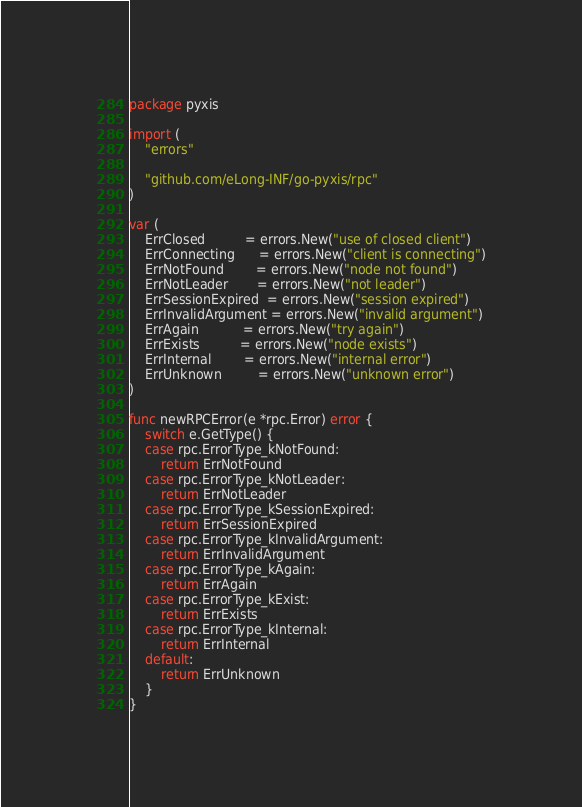Convert code to text. <code><loc_0><loc_0><loc_500><loc_500><_Go_>package pyxis

import (
	"errors"

	"github.com/eLong-INF/go-pyxis/rpc"
)

var (
	ErrClosed          = errors.New("use of closed client")
	ErrConnecting      = errors.New("client is connecting")
	ErrNotFound        = errors.New("node not found")
	ErrNotLeader       = errors.New("not leader")
	ErrSessionExpired  = errors.New("session expired")
	ErrInvalidArgument = errors.New("invalid argument")
	ErrAgain           = errors.New("try again")
	ErrExists          = errors.New("node exists")
	ErrInternal        = errors.New("internal error")
	ErrUnknown         = errors.New("unknown error")
)

func newRPCError(e *rpc.Error) error {
	switch e.GetType() {
	case rpc.ErrorType_kNotFound:
		return ErrNotFound
	case rpc.ErrorType_kNotLeader:
		return ErrNotLeader
	case rpc.ErrorType_kSessionExpired:
		return ErrSessionExpired
	case rpc.ErrorType_kInvalidArgument:
		return ErrInvalidArgument
	case rpc.ErrorType_kAgain:
		return ErrAgain
	case rpc.ErrorType_kExist:
		return ErrExists
	case rpc.ErrorType_kInternal:
		return ErrInternal
	default:
		return ErrUnknown
	}
}
</code> 